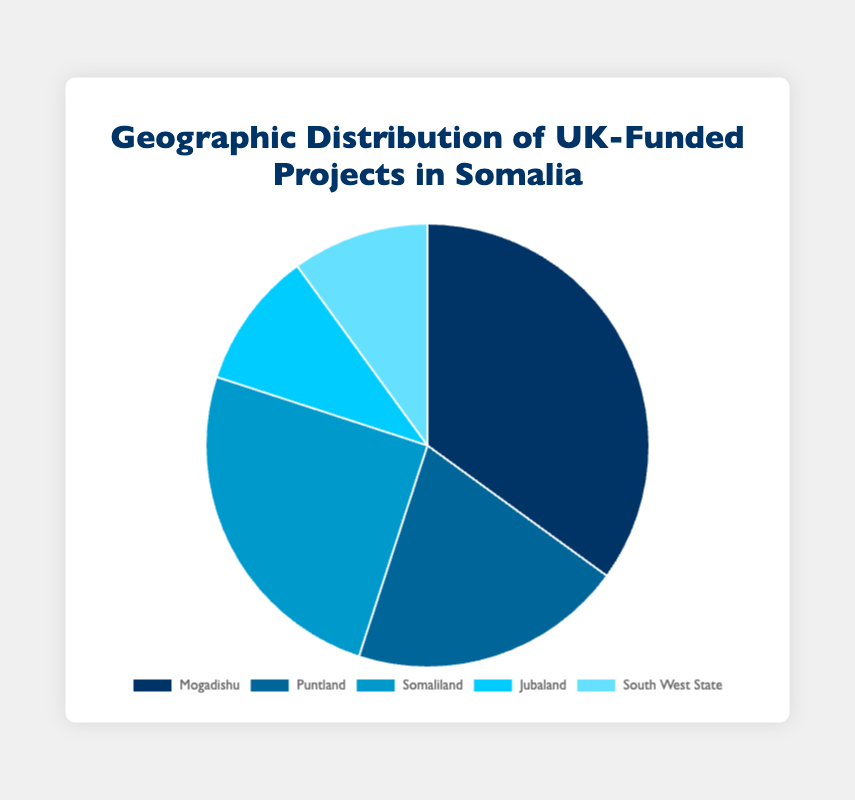Which region receives the highest percentage of UK-funded projects in Somalia? The pie chart shows that Mogadishu receives the largest share.
Answer: Mogadishu What is the total percentage of UK-funded projects in Somaliland and Puntland combined? The pie chart indicates Somaliland has 25% and Puntland has 20%. Adding these gives 25% + 20% = 45%.
Answer: 45% Does Jubaland receive the same amount of funding as South West State from UK-funded projects? Both Jubaland and South West State each have a 10% share as per the pie chart, indicating they receive equal funding.
Answer: Yes How much greater is the funding percentage for Mogadishu compared to Jubaland? Mogadishu has 35%, while Jubaland has 10%. The difference is 35% - 10% = 25%.
Answer: 25% Which three regions have the smallest shares of UK-funded projects? According to the pie chart, Jubaland and South West State each have 10%, and Puntland has 20%. These are the smallest shares compared to the other regions.
Answer: Jubaland, South West State, Puntland If the total number of UK-funded projects is 100, how many projects are in Somaliland? Somaliland has a 25% share. If there are 100 projects, then 25% corresponds to 100 * 0.25 = 25 projects.
Answer: 25 Rank the regions from highest to lowest in terms of their share of UK-funded projects. According to the pie chart: Mogadishu (35%), Somaliland (25%), Puntland (20%), Jubaland and South West State (both 10%).
Answer: Mogadishu, Somaliland, Puntland, Jubaland, South West State What percentage of the projects is allocated outside Mogadishu? Excluding Mogadishu’s 35%, the remaining percentage sums up to 100% - 35% = 65%.
Answer: 65% If UK decided to double its funding to Puntland, what would be the new percentage share for Puntland assuming other regions' shares remain the same? Currently, Puntland’s share is 20%. Doubling this would theoretically mean 20% * 2 = 40%. However, the total must be recalculated since we are considering the pie chart (out of 100%). The remaining 60% is from the other regions combined. Therefore, the new distribution means Puntland's share within the new total: (40/(100+20)) * 100 = 33.3%.
Answer: 33.3% How does the funding for Puntland compare to South West State in terms of visual size on the pie chart? The pie chart shows Puntland with a segment larger than South West State's, representing 20% for Puntland versus 10% for South West State.
Answer: Larger 